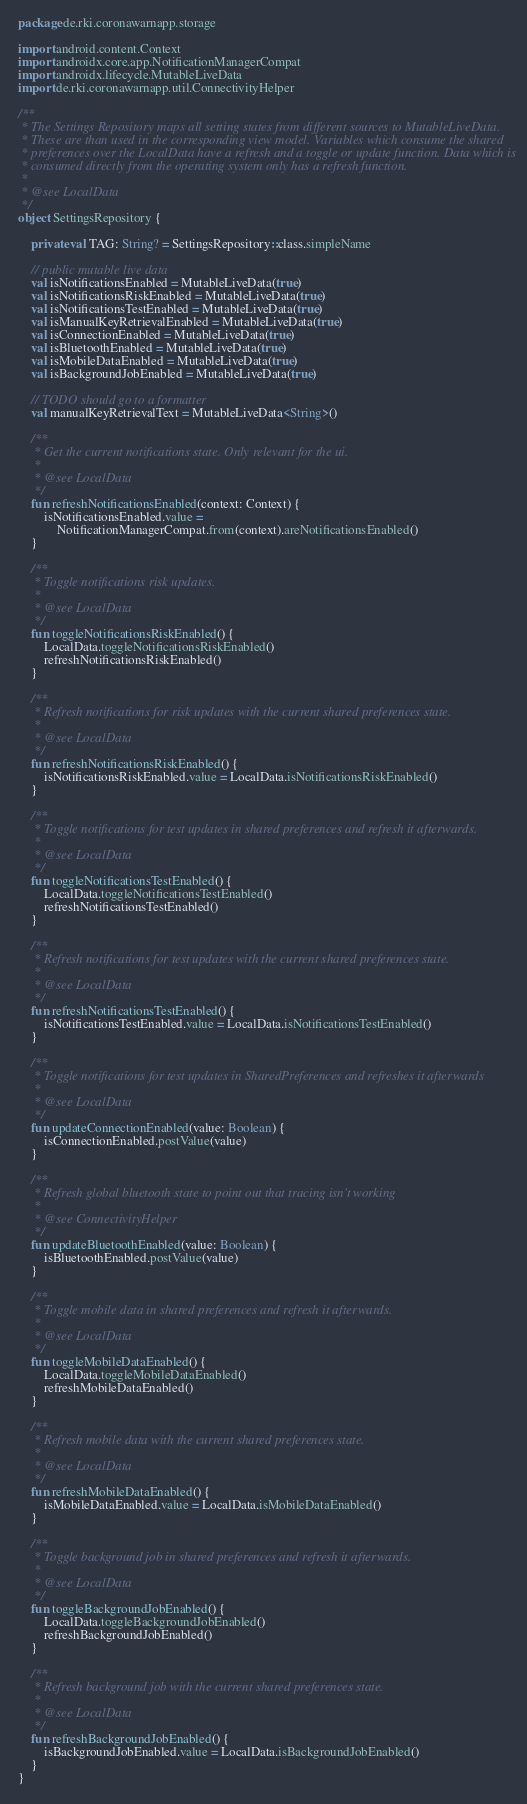<code> <loc_0><loc_0><loc_500><loc_500><_Kotlin_>package de.rki.coronawarnapp.storage

import android.content.Context
import androidx.core.app.NotificationManagerCompat
import androidx.lifecycle.MutableLiveData
import de.rki.coronawarnapp.util.ConnectivityHelper

/**
 * The Settings Repository maps all setting states from different sources to MutableLiveData.
 * These are than used in the corresponding view model. Variables which consume the shared
 * preferences over the LocalData have a refresh and a toggle or update function. Data which is
 * consumed directly from the operating system only has a refresh function.
 *
 * @see LocalData
 */
object SettingsRepository {

    private val TAG: String? = SettingsRepository::class.simpleName

    // public mutable live data
    val isNotificationsEnabled = MutableLiveData(true)
    val isNotificationsRiskEnabled = MutableLiveData(true)
    val isNotificationsTestEnabled = MutableLiveData(true)
    val isManualKeyRetrievalEnabled = MutableLiveData(true)
    val isConnectionEnabled = MutableLiveData(true)
    val isBluetoothEnabled = MutableLiveData(true)
    val isMobileDataEnabled = MutableLiveData(true)
    val isBackgroundJobEnabled = MutableLiveData(true)

    // TODO should go to a formatter
    val manualKeyRetrievalText = MutableLiveData<String>()

    /**
     * Get the current notifications state. Only relevant for the ui.
     *
     * @see LocalData
     */
    fun refreshNotificationsEnabled(context: Context) {
        isNotificationsEnabled.value =
            NotificationManagerCompat.from(context).areNotificationsEnabled()
    }

    /**
     * Toggle notifications risk updates.
     *
     * @see LocalData
     */
    fun toggleNotificationsRiskEnabled() {
        LocalData.toggleNotificationsRiskEnabled()
        refreshNotificationsRiskEnabled()
    }

    /**
     * Refresh notifications for risk updates with the current shared preferences state.
     *
     * @see LocalData
     */
    fun refreshNotificationsRiskEnabled() {
        isNotificationsRiskEnabled.value = LocalData.isNotificationsRiskEnabled()
    }

    /**
     * Toggle notifications for test updates in shared preferences and refresh it afterwards.
     *
     * @see LocalData
     */
    fun toggleNotificationsTestEnabled() {
        LocalData.toggleNotificationsTestEnabled()
        refreshNotificationsTestEnabled()
    }

    /**
     * Refresh notifications for test updates with the current shared preferences state.
     *
     * @see LocalData
     */
    fun refreshNotificationsTestEnabled() {
        isNotificationsTestEnabled.value = LocalData.isNotificationsTestEnabled()
    }

    /**
     * Toggle notifications for test updates in SharedPreferences and refreshes it afterwards
     *
     * @see LocalData
     */
    fun updateConnectionEnabled(value: Boolean) {
        isConnectionEnabled.postValue(value)
    }

    /**
     * Refresh global bluetooth state to point out that tracing isn't working
     *
     * @see ConnectivityHelper
     */
    fun updateBluetoothEnabled(value: Boolean) {
        isBluetoothEnabled.postValue(value)
    }

    /**
     * Toggle mobile data in shared preferences and refresh it afterwards.
     *
     * @see LocalData
     */
    fun toggleMobileDataEnabled() {
        LocalData.toggleMobileDataEnabled()
        refreshMobileDataEnabled()
    }

    /**
     * Refresh mobile data with the current shared preferences state.
     *
     * @see LocalData
     */
    fun refreshMobileDataEnabled() {
        isMobileDataEnabled.value = LocalData.isMobileDataEnabled()
    }

    /**
     * Toggle background job in shared preferences and refresh it afterwards.
     *
     * @see LocalData
     */
    fun toggleBackgroundJobEnabled() {
        LocalData.toggleBackgroundJobEnabled()
        refreshBackgroundJobEnabled()
    }

    /**
     * Refresh background job with the current shared preferences state.
     *
     * @see LocalData
     */
    fun refreshBackgroundJobEnabled() {
        isBackgroundJobEnabled.value = LocalData.isBackgroundJobEnabled()
    }
}
</code> 